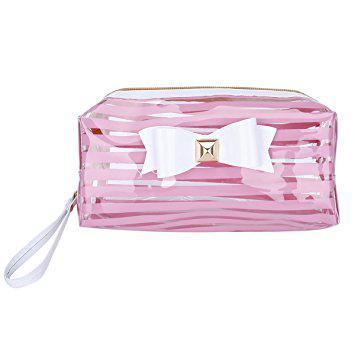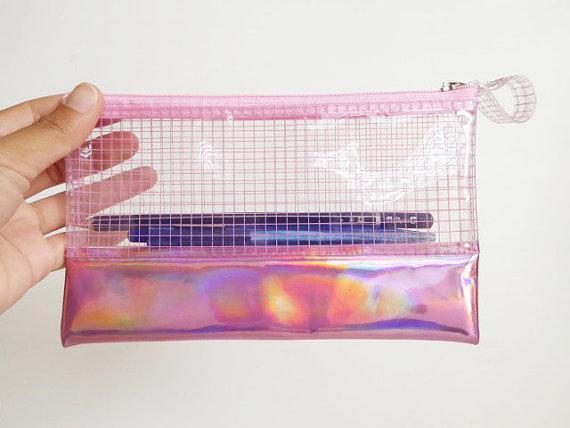The first image is the image on the left, the second image is the image on the right. Analyze the images presented: Is the assertion "There are exactly two translucent pencil pouches." valid? Answer yes or no. Yes. 